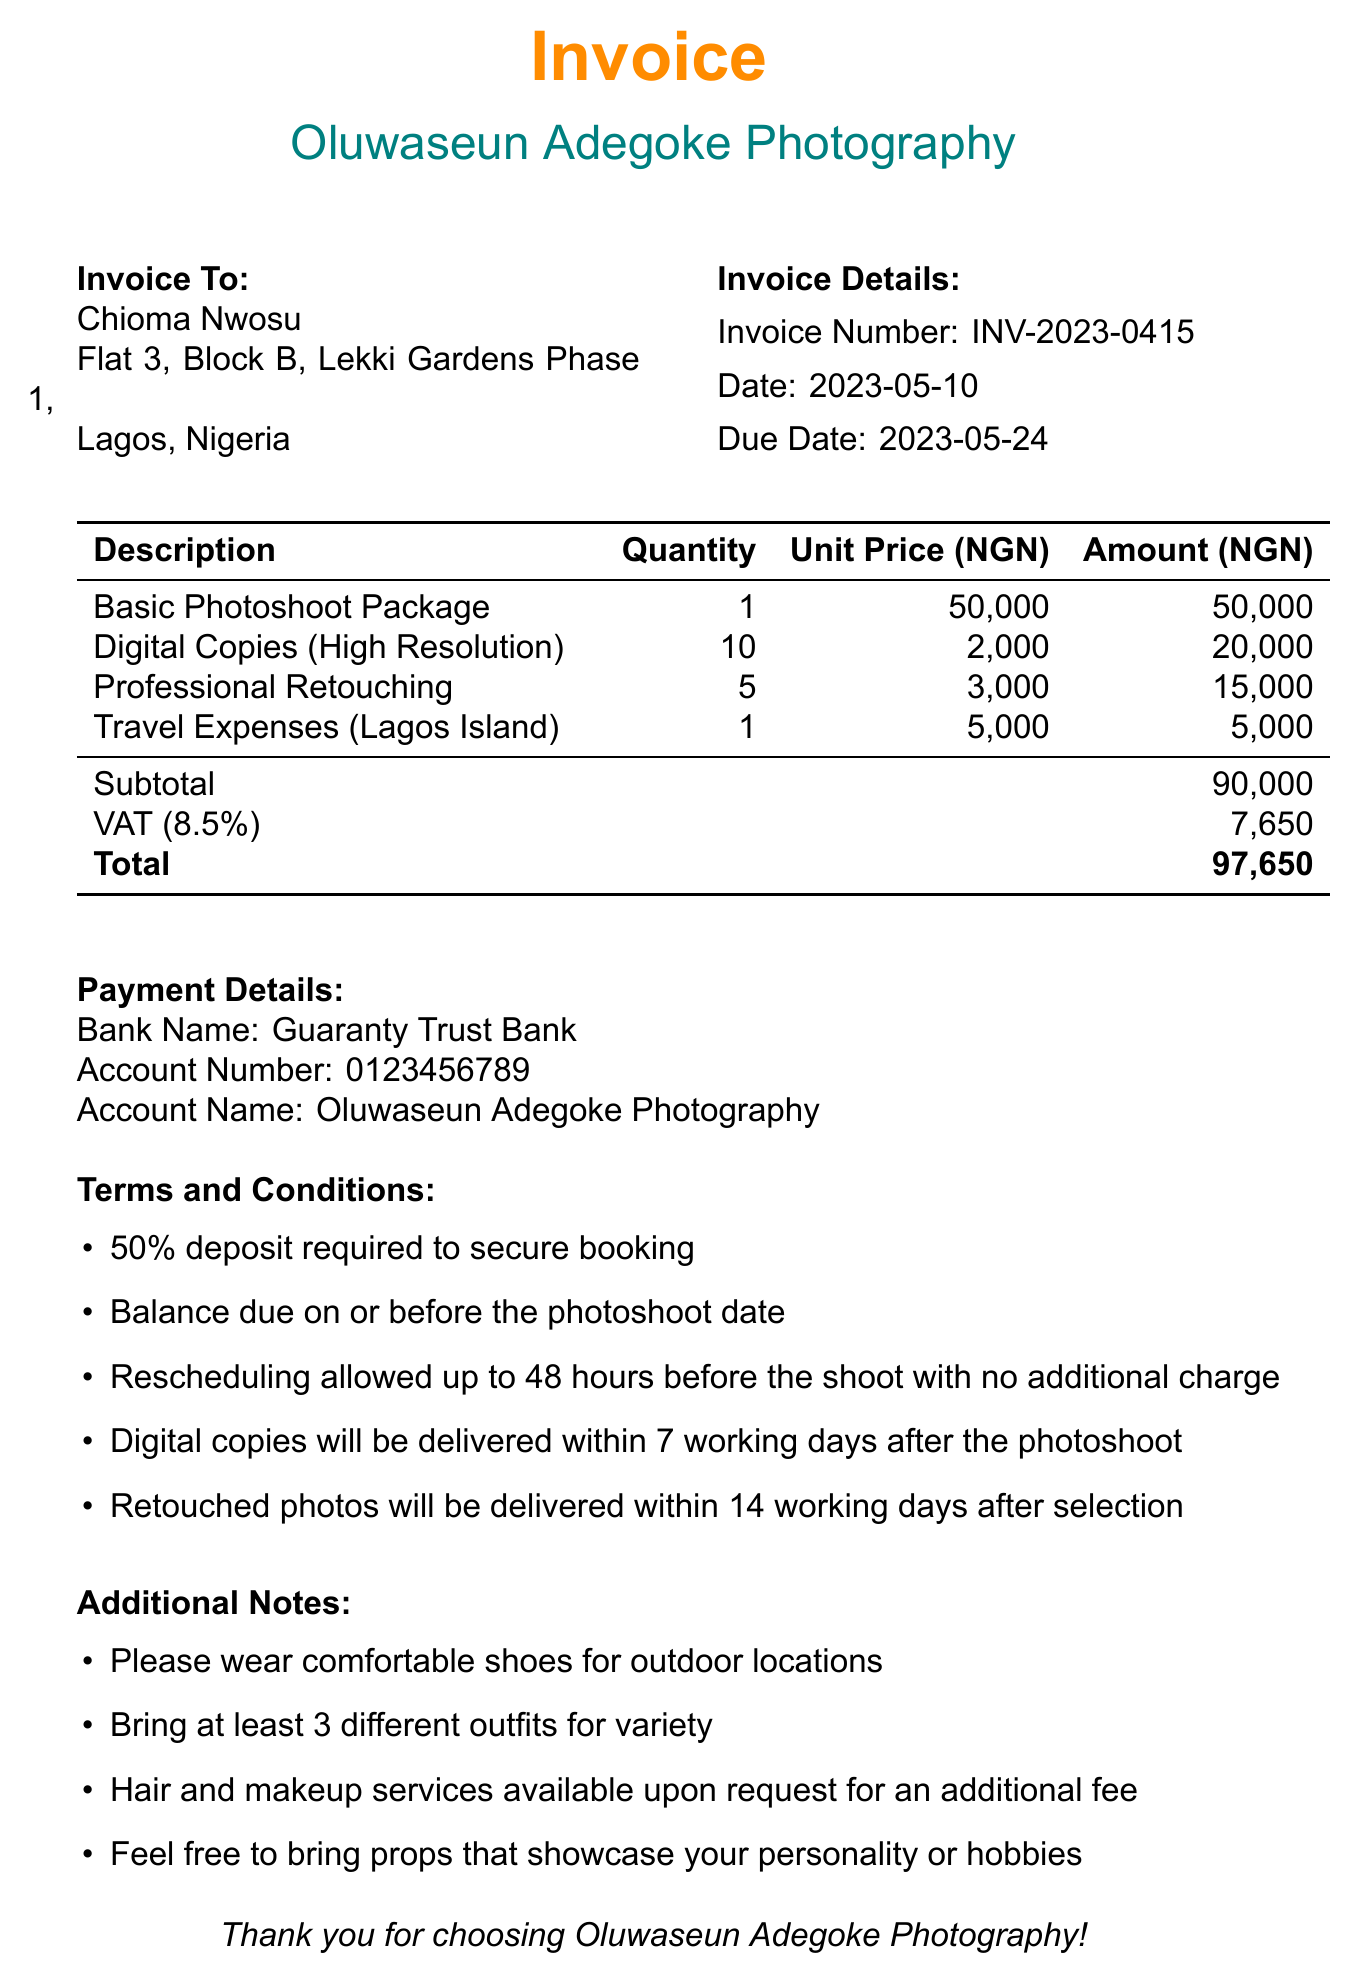What is the invoice number? The invoice number is listed in the invoice details section of the document.
Answer: INV-2023-0415 Who is the photographer? The photographer's name is specified in the invoice details.
Answer: Oluwaseun Adegoke What is the total amount due? The total amount due is listed in the payment details section at the end of the document.
Answer: 97,650 How many digital copies are included? The quantity of digital copies is specified in the line items section.
Answer: 10 What is the duration of the photoshoot? The duration of the photoshoot is stated in the package details section.
Answer: 3 hours What is the payment method? The payment method is described in the payment details section of the document.
Answer: Bank Transfer What percentage deposit is required to secure the booking? The required deposit percentage is mentioned in the terms and conditions section.
Answer: 50% What type of services are available upon request? Additional services available are mentioned in the additional notes section of the document.
Answer: Hair and makeup services 